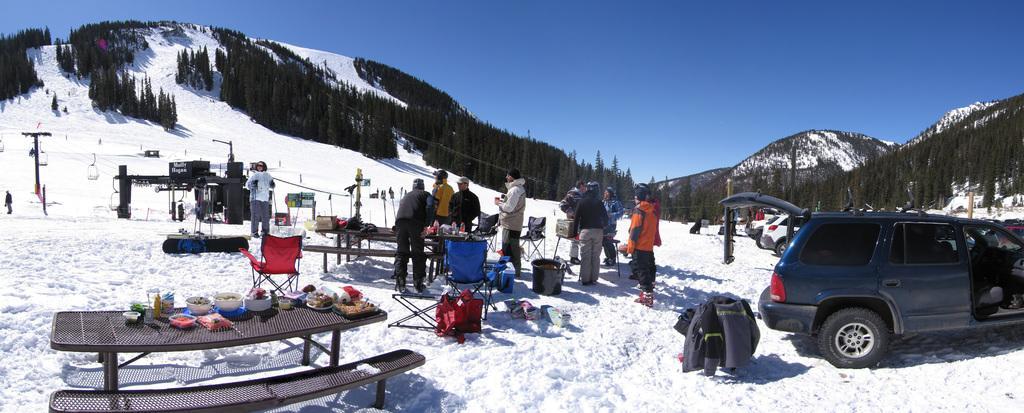In one or two sentences, can you explain what this image depicts? In this image we can see these people are standing on the snow, we can see the table on which we can see some objects are kept, we can see chairs, a few more objects, rope-way, trees, mountains and the blue sky in the background. 